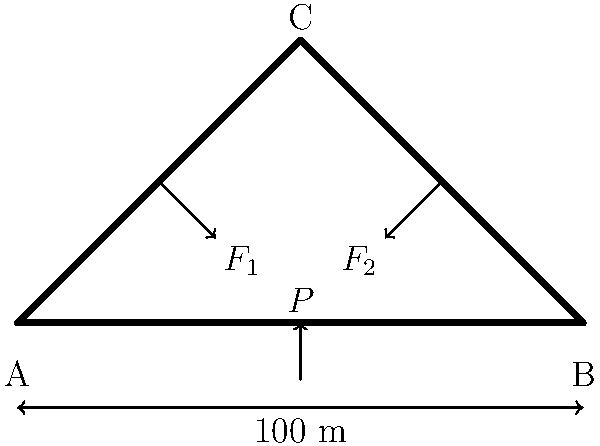As the editor overseeing a story on local infrastructure, you've received a structural diagram of a bridge proposed by the mayor's office. The bridge spans 100 meters and has a central peak 50 meters high. If a concentrated load $P$ of 500 kN is applied at the midpoint, and the angles between the horizontal and the bridge sides are both 45°, calculate the compressive forces $F_1$ and $F_2$ in the bridge's main support beams. Assume the bridge is perfectly symmetrical and ignore the weight of the structure itself. To solve this problem, we'll follow these steps:

1) First, we need to understand that due to symmetry, $F_1 = F_2$. Let's call this force $F$.

2) We can break down the force $F$ into horizontal and vertical components:
   $F_x = F \cos 45°$
   $F_y = F \sin 45°$

3) The vertical components of $F_1$ and $F_2$ must balance the applied load $P$:
   $2F_y = P$
   $2F \sin 45° = 500$ kN

4) We know that $\sin 45° = \frac{1}{\sqrt{2}}$, so:
   $2F \cdot \frac{1}{\sqrt{2}} = 500$ kN

5) Solving for $F$:
   $F = \frac{500 \cdot \sqrt{2}}{2} = 250\sqrt{2}$ kN

6) This is the magnitude of both $F_1$ and $F_2$.

Therefore, the compressive force in each of the main support beams is $250\sqrt{2}$ kN, or approximately 353.55 kN.
Answer: $F_1 = F_2 = 250\sqrt{2}$ kN ≈ 353.55 kN 